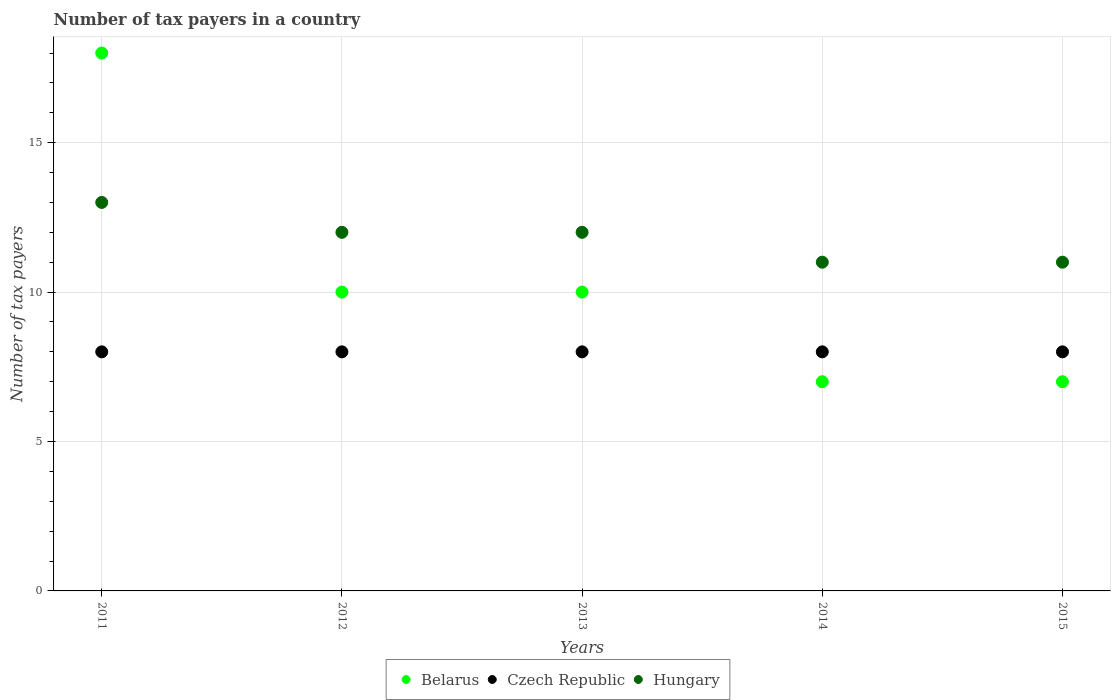What is the number of tax payers in in Hungary in 2015?
Offer a very short reply. 11. Across all years, what is the maximum number of tax payers in in Belarus?
Provide a short and direct response. 18. Across all years, what is the minimum number of tax payers in in Czech Republic?
Your answer should be very brief. 8. In which year was the number of tax payers in in Hungary maximum?
Keep it short and to the point. 2011. What is the total number of tax payers in in Hungary in the graph?
Make the answer very short. 59. What is the difference between the number of tax payers in in Belarus in 2013 and that in 2014?
Offer a terse response. 3. What is the difference between the number of tax payers in in Belarus in 2013 and the number of tax payers in in Czech Republic in 2014?
Make the answer very short. 2. In the year 2015, what is the difference between the number of tax payers in in Czech Republic and number of tax payers in in Belarus?
Your answer should be compact. 1. What is the ratio of the number of tax payers in in Belarus in 2011 to that in 2013?
Ensure brevity in your answer.  1.8. Is the number of tax payers in in Czech Republic in 2011 less than that in 2015?
Provide a short and direct response. No. Is the difference between the number of tax payers in in Czech Republic in 2012 and 2015 greater than the difference between the number of tax payers in in Belarus in 2012 and 2015?
Provide a short and direct response. No. What is the difference between the highest and the lowest number of tax payers in in Belarus?
Offer a terse response. 11. In how many years, is the number of tax payers in in Belarus greater than the average number of tax payers in in Belarus taken over all years?
Your answer should be very brief. 1. Is the sum of the number of tax payers in in Belarus in 2012 and 2015 greater than the maximum number of tax payers in in Czech Republic across all years?
Offer a terse response. Yes. Is it the case that in every year, the sum of the number of tax payers in in Belarus and number of tax payers in in Hungary  is greater than the number of tax payers in in Czech Republic?
Offer a very short reply. Yes. Does the number of tax payers in in Belarus monotonically increase over the years?
Give a very brief answer. No. How many dotlines are there?
Your answer should be very brief. 3. How many years are there in the graph?
Keep it short and to the point. 5. What is the difference between two consecutive major ticks on the Y-axis?
Give a very brief answer. 5. Does the graph contain any zero values?
Provide a succinct answer. No. Does the graph contain grids?
Provide a short and direct response. Yes. How many legend labels are there?
Offer a very short reply. 3. How are the legend labels stacked?
Provide a short and direct response. Horizontal. What is the title of the graph?
Your answer should be very brief. Number of tax payers in a country. What is the label or title of the Y-axis?
Give a very brief answer. Number of tax payers. What is the Number of tax payers in Belarus in 2011?
Ensure brevity in your answer.  18. What is the Number of tax payers of Czech Republic in 2011?
Offer a very short reply. 8. What is the Number of tax payers of Belarus in 2012?
Your answer should be very brief. 10. What is the Number of tax payers in Belarus in 2013?
Your answer should be very brief. 10. What is the Number of tax payers in Czech Republic in 2013?
Your answer should be compact. 8. What is the Number of tax payers of Hungary in 2013?
Offer a terse response. 12. What is the Number of tax payers in Belarus in 2014?
Your response must be concise. 7. What is the Number of tax payers in Hungary in 2014?
Your answer should be very brief. 11. What is the Number of tax payers of Czech Republic in 2015?
Your response must be concise. 8. Across all years, what is the maximum Number of tax payers in Belarus?
Your answer should be very brief. 18. Across all years, what is the minimum Number of tax payers of Hungary?
Provide a short and direct response. 11. What is the total Number of tax payers in Belarus in the graph?
Provide a short and direct response. 52. What is the total Number of tax payers in Czech Republic in the graph?
Your answer should be very brief. 40. What is the difference between the Number of tax payers in Hungary in 2011 and that in 2012?
Offer a terse response. 1. What is the difference between the Number of tax payers of Czech Republic in 2011 and that in 2014?
Provide a succinct answer. 0. What is the difference between the Number of tax payers of Hungary in 2011 and that in 2014?
Provide a short and direct response. 2. What is the difference between the Number of tax payers in Czech Republic in 2011 and that in 2015?
Provide a short and direct response. 0. What is the difference between the Number of tax payers in Belarus in 2012 and that in 2013?
Make the answer very short. 0. What is the difference between the Number of tax payers of Czech Republic in 2012 and that in 2013?
Your answer should be compact. 0. What is the difference between the Number of tax payers of Hungary in 2012 and that in 2013?
Your answer should be very brief. 0. What is the difference between the Number of tax payers of Belarus in 2012 and that in 2014?
Provide a short and direct response. 3. What is the difference between the Number of tax payers of Hungary in 2012 and that in 2014?
Make the answer very short. 1. What is the difference between the Number of tax payers in Czech Republic in 2012 and that in 2015?
Ensure brevity in your answer.  0. What is the difference between the Number of tax payers in Hungary in 2012 and that in 2015?
Your response must be concise. 1. What is the difference between the Number of tax payers in Belarus in 2013 and that in 2015?
Offer a terse response. 3. What is the difference between the Number of tax payers in Belarus in 2014 and that in 2015?
Keep it short and to the point. 0. What is the difference between the Number of tax payers of Belarus in 2011 and the Number of tax payers of Czech Republic in 2012?
Keep it short and to the point. 10. What is the difference between the Number of tax payers in Belarus in 2011 and the Number of tax payers in Hungary in 2012?
Keep it short and to the point. 6. What is the difference between the Number of tax payers in Czech Republic in 2011 and the Number of tax payers in Hungary in 2012?
Keep it short and to the point. -4. What is the difference between the Number of tax payers of Belarus in 2011 and the Number of tax payers of Czech Republic in 2013?
Provide a succinct answer. 10. What is the difference between the Number of tax payers of Belarus in 2011 and the Number of tax payers of Hungary in 2013?
Provide a succinct answer. 6. What is the difference between the Number of tax payers of Belarus in 2011 and the Number of tax payers of Hungary in 2014?
Give a very brief answer. 7. What is the difference between the Number of tax payers in Belarus in 2011 and the Number of tax payers in Czech Republic in 2015?
Provide a succinct answer. 10. What is the difference between the Number of tax payers in Czech Republic in 2011 and the Number of tax payers in Hungary in 2015?
Make the answer very short. -3. What is the difference between the Number of tax payers in Czech Republic in 2012 and the Number of tax payers in Hungary in 2015?
Keep it short and to the point. -3. What is the difference between the Number of tax payers of Belarus in 2013 and the Number of tax payers of Czech Republic in 2014?
Ensure brevity in your answer.  2. What is the difference between the Number of tax payers of Belarus in 2013 and the Number of tax payers of Hungary in 2014?
Offer a very short reply. -1. What is the difference between the Number of tax payers of Czech Republic in 2013 and the Number of tax payers of Hungary in 2015?
Offer a terse response. -3. What is the difference between the Number of tax payers in Czech Republic in 2014 and the Number of tax payers in Hungary in 2015?
Your response must be concise. -3. What is the average Number of tax payers in Hungary per year?
Your response must be concise. 11.8. In the year 2011, what is the difference between the Number of tax payers of Belarus and Number of tax payers of Czech Republic?
Provide a succinct answer. 10. In the year 2011, what is the difference between the Number of tax payers of Belarus and Number of tax payers of Hungary?
Your answer should be very brief. 5. In the year 2011, what is the difference between the Number of tax payers in Czech Republic and Number of tax payers in Hungary?
Offer a terse response. -5. In the year 2012, what is the difference between the Number of tax payers in Czech Republic and Number of tax payers in Hungary?
Provide a succinct answer. -4. In the year 2013, what is the difference between the Number of tax payers of Belarus and Number of tax payers of Hungary?
Offer a terse response. -2. In the year 2013, what is the difference between the Number of tax payers of Czech Republic and Number of tax payers of Hungary?
Provide a succinct answer. -4. In the year 2014, what is the difference between the Number of tax payers in Belarus and Number of tax payers in Czech Republic?
Your answer should be very brief. -1. In the year 2014, what is the difference between the Number of tax payers in Belarus and Number of tax payers in Hungary?
Offer a terse response. -4. In the year 2014, what is the difference between the Number of tax payers in Czech Republic and Number of tax payers in Hungary?
Give a very brief answer. -3. In the year 2015, what is the difference between the Number of tax payers in Belarus and Number of tax payers in Czech Republic?
Your response must be concise. -1. In the year 2015, what is the difference between the Number of tax payers in Belarus and Number of tax payers in Hungary?
Provide a short and direct response. -4. In the year 2015, what is the difference between the Number of tax payers in Czech Republic and Number of tax payers in Hungary?
Offer a terse response. -3. What is the ratio of the Number of tax payers of Belarus in 2011 to that in 2012?
Offer a very short reply. 1.8. What is the ratio of the Number of tax payers of Hungary in 2011 to that in 2012?
Give a very brief answer. 1.08. What is the ratio of the Number of tax payers of Czech Republic in 2011 to that in 2013?
Offer a very short reply. 1. What is the ratio of the Number of tax payers in Belarus in 2011 to that in 2014?
Offer a very short reply. 2.57. What is the ratio of the Number of tax payers of Czech Republic in 2011 to that in 2014?
Make the answer very short. 1. What is the ratio of the Number of tax payers in Hungary in 2011 to that in 2014?
Offer a terse response. 1.18. What is the ratio of the Number of tax payers of Belarus in 2011 to that in 2015?
Your answer should be very brief. 2.57. What is the ratio of the Number of tax payers of Czech Republic in 2011 to that in 2015?
Ensure brevity in your answer.  1. What is the ratio of the Number of tax payers in Hungary in 2011 to that in 2015?
Your answer should be compact. 1.18. What is the ratio of the Number of tax payers of Czech Republic in 2012 to that in 2013?
Make the answer very short. 1. What is the ratio of the Number of tax payers in Hungary in 2012 to that in 2013?
Your answer should be compact. 1. What is the ratio of the Number of tax payers in Belarus in 2012 to that in 2014?
Your answer should be very brief. 1.43. What is the ratio of the Number of tax payers in Belarus in 2012 to that in 2015?
Make the answer very short. 1.43. What is the ratio of the Number of tax payers in Czech Republic in 2012 to that in 2015?
Ensure brevity in your answer.  1. What is the ratio of the Number of tax payers of Belarus in 2013 to that in 2014?
Keep it short and to the point. 1.43. What is the ratio of the Number of tax payers in Belarus in 2013 to that in 2015?
Offer a terse response. 1.43. What is the ratio of the Number of tax payers of Hungary in 2013 to that in 2015?
Keep it short and to the point. 1.09. What is the ratio of the Number of tax payers of Belarus in 2014 to that in 2015?
Offer a very short reply. 1. What is the ratio of the Number of tax payers in Hungary in 2014 to that in 2015?
Provide a short and direct response. 1. What is the difference between the highest and the second highest Number of tax payers in Belarus?
Ensure brevity in your answer.  8. What is the difference between the highest and the lowest Number of tax payers in Czech Republic?
Offer a terse response. 0. What is the difference between the highest and the lowest Number of tax payers in Hungary?
Keep it short and to the point. 2. 